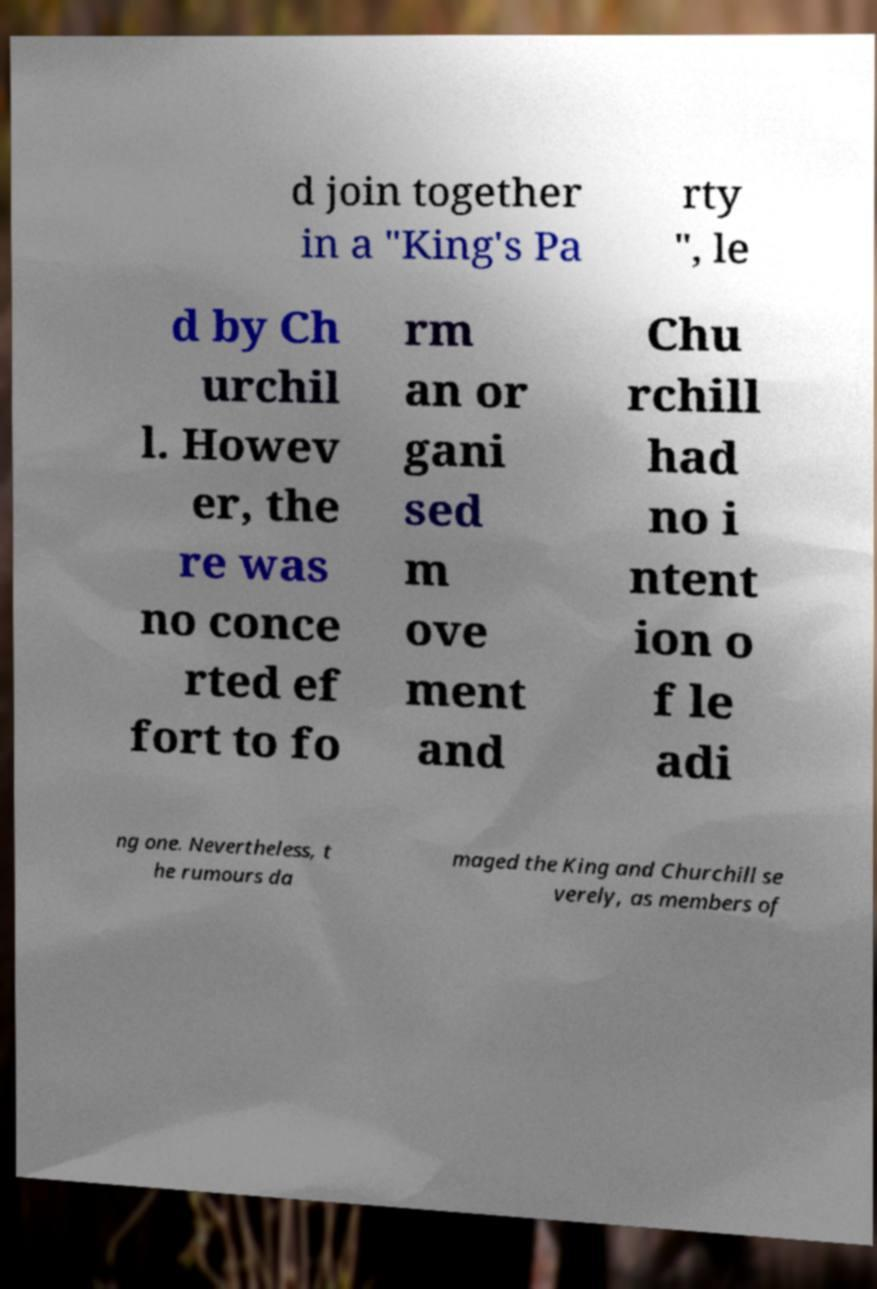Could you assist in decoding the text presented in this image and type it out clearly? d join together in a "King's Pa rty ", le d by Ch urchil l. Howev er, the re was no conce rted ef fort to fo rm an or gani sed m ove ment and Chu rchill had no i ntent ion o f le adi ng one. Nevertheless, t he rumours da maged the King and Churchill se verely, as members of 